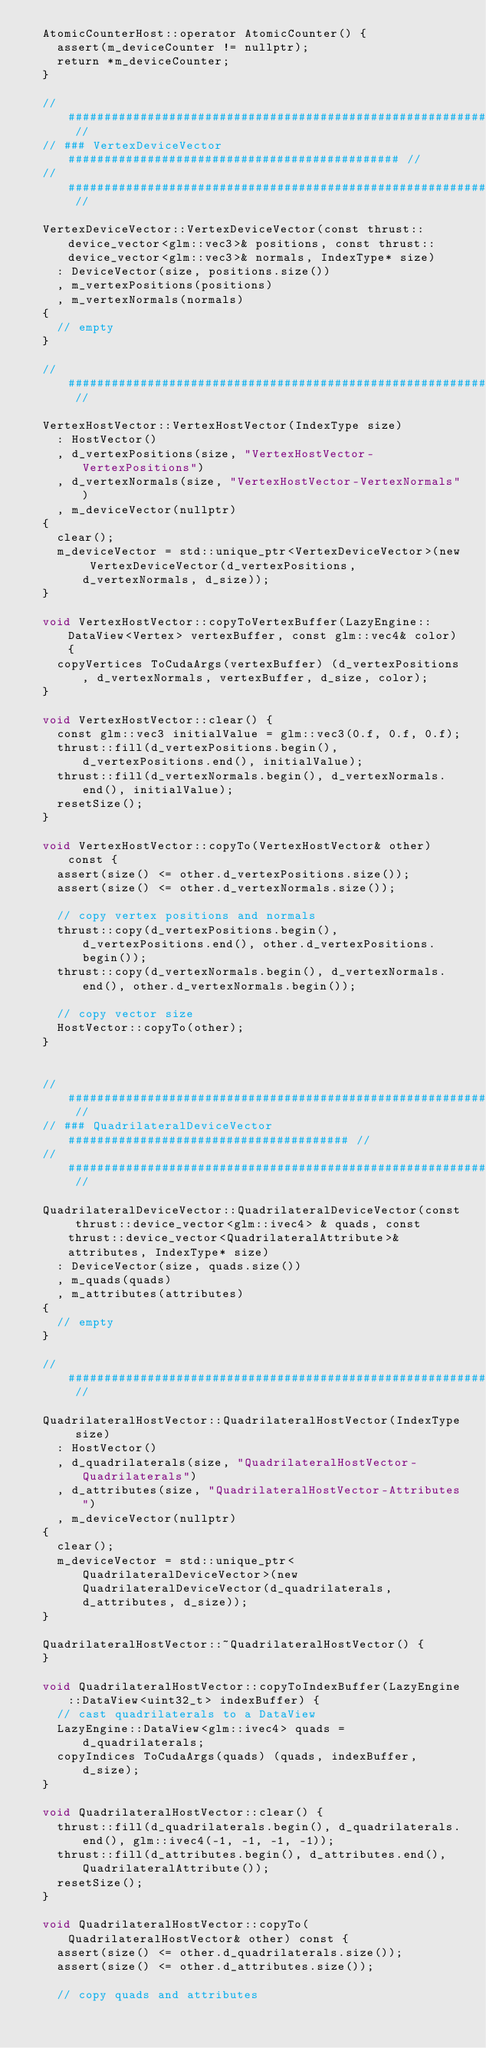Convert code to text. <code><loc_0><loc_0><loc_500><loc_500><_Cuda_>	AtomicCounterHost::operator AtomicCounter() {
		assert(m_deviceCounter != nullptr);
		return *m_deviceCounter;
	}

	// ##################################################################### //
	// ### VertexDeviceVector ############################################## //
	// ##################################################################### //

	VertexDeviceVector::VertexDeviceVector(const thrust::device_vector<glm::vec3>& positions, const thrust::device_vector<glm::vec3>& normals, IndexType* size)
		: DeviceVector(size, positions.size())
		, m_vertexPositions(positions)
		, m_vertexNormals(normals)
	{
		// empty
	}

	// ##################################################################### //

	VertexHostVector::VertexHostVector(IndexType size)
		: HostVector()
		, d_vertexPositions(size, "VertexHostVector-VertexPositions")
		, d_vertexNormals(size, "VertexHostVector-VertexNormals")
		, m_deviceVector(nullptr)
	{
		clear();
		m_deviceVector = std::unique_ptr<VertexDeviceVector>(new VertexDeviceVector(d_vertexPositions, d_vertexNormals, d_size));
	}

	void VertexHostVector::copyToVertexBuffer(LazyEngine::DataView<Vertex> vertexBuffer, const glm::vec4& color) {
		copyVertices ToCudaArgs(vertexBuffer) (d_vertexPositions, d_vertexNormals, vertexBuffer, d_size, color);
	}

	void VertexHostVector::clear() {
		const glm::vec3 initialValue = glm::vec3(0.f, 0.f, 0.f);
		thrust::fill(d_vertexPositions.begin(), d_vertexPositions.end(), initialValue);
		thrust::fill(d_vertexNormals.begin(), d_vertexNormals.end(), initialValue);
		resetSize();
	}

	void VertexHostVector::copyTo(VertexHostVector& other) const {
		assert(size() <= other.d_vertexPositions.size());
		assert(size() <= other.d_vertexNormals.size());
		
		// copy vertex positions and normals
		thrust::copy(d_vertexPositions.begin(), d_vertexPositions.end(), other.d_vertexPositions.begin());
		thrust::copy(d_vertexNormals.begin(), d_vertexNormals.end(), other.d_vertexNormals.begin());
		
		// copy vector size
		HostVector::copyTo(other);
	}


	// ##################################################################### //
	// ### QuadrilateralDeviceVector ####################################### //
	// ##################################################################### //

	QuadrilateralDeviceVector::QuadrilateralDeviceVector(const thrust::device_vector<glm::ivec4> & quads, const thrust::device_vector<QuadrilateralAttribute>& attributes, IndexType* size)
		: DeviceVector(size, quads.size())
		, m_quads(quads)
		, m_attributes(attributes)
	{
		// empty
	}

	// ##################################################################### //

	QuadrilateralHostVector::QuadrilateralHostVector(IndexType size)
		: HostVector()
		, d_quadrilaterals(size, "QuadrilateralHostVector-Quadrilaterals")
		, d_attributes(size, "QuadrilateralHostVector-Attributes")
		, m_deviceVector(nullptr)
	{
		clear();
		m_deviceVector = std::unique_ptr<QuadrilateralDeviceVector>(new QuadrilateralDeviceVector(d_quadrilaterals, d_attributes, d_size));
	}

	QuadrilateralHostVector::~QuadrilateralHostVector() {
	}

	void QuadrilateralHostVector::copyToIndexBuffer(LazyEngine::DataView<uint32_t> indexBuffer) {
		// cast quadrilaterals to a DataView
		LazyEngine::DataView<glm::ivec4> quads = d_quadrilaterals;
		copyIndices ToCudaArgs(quads) (quads, indexBuffer, d_size);
	}

	void QuadrilateralHostVector::clear() {
		thrust::fill(d_quadrilaterals.begin(), d_quadrilaterals.end(), glm::ivec4(-1, -1, -1, -1));
		thrust::fill(d_attributes.begin(), d_attributes.end(), QuadrilateralAttribute());
		resetSize();
	}

	void QuadrilateralHostVector::copyTo(QuadrilateralHostVector& other) const {
		assert(size() <= other.d_quadrilaterals.size());
		assert(size() <= other.d_attributes.size());

		// copy quads and attributes</code> 